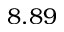<formula> <loc_0><loc_0><loc_500><loc_500>8 . 8 9</formula> 